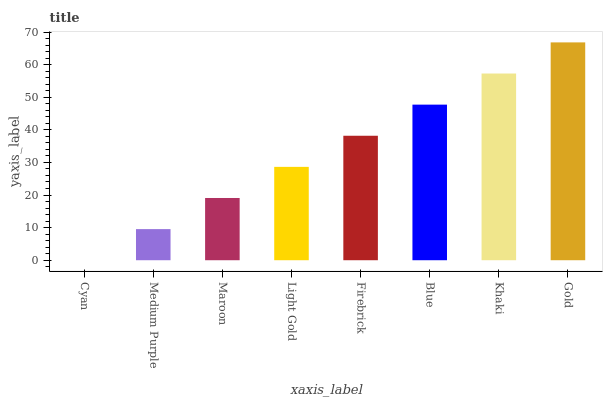Is Cyan the minimum?
Answer yes or no. Yes. Is Gold the maximum?
Answer yes or no. Yes. Is Medium Purple the minimum?
Answer yes or no. No. Is Medium Purple the maximum?
Answer yes or no. No. Is Medium Purple greater than Cyan?
Answer yes or no. Yes. Is Cyan less than Medium Purple?
Answer yes or no. Yes. Is Cyan greater than Medium Purple?
Answer yes or no. No. Is Medium Purple less than Cyan?
Answer yes or no. No. Is Firebrick the high median?
Answer yes or no. Yes. Is Light Gold the low median?
Answer yes or no. Yes. Is Gold the high median?
Answer yes or no. No. Is Medium Purple the low median?
Answer yes or no. No. 